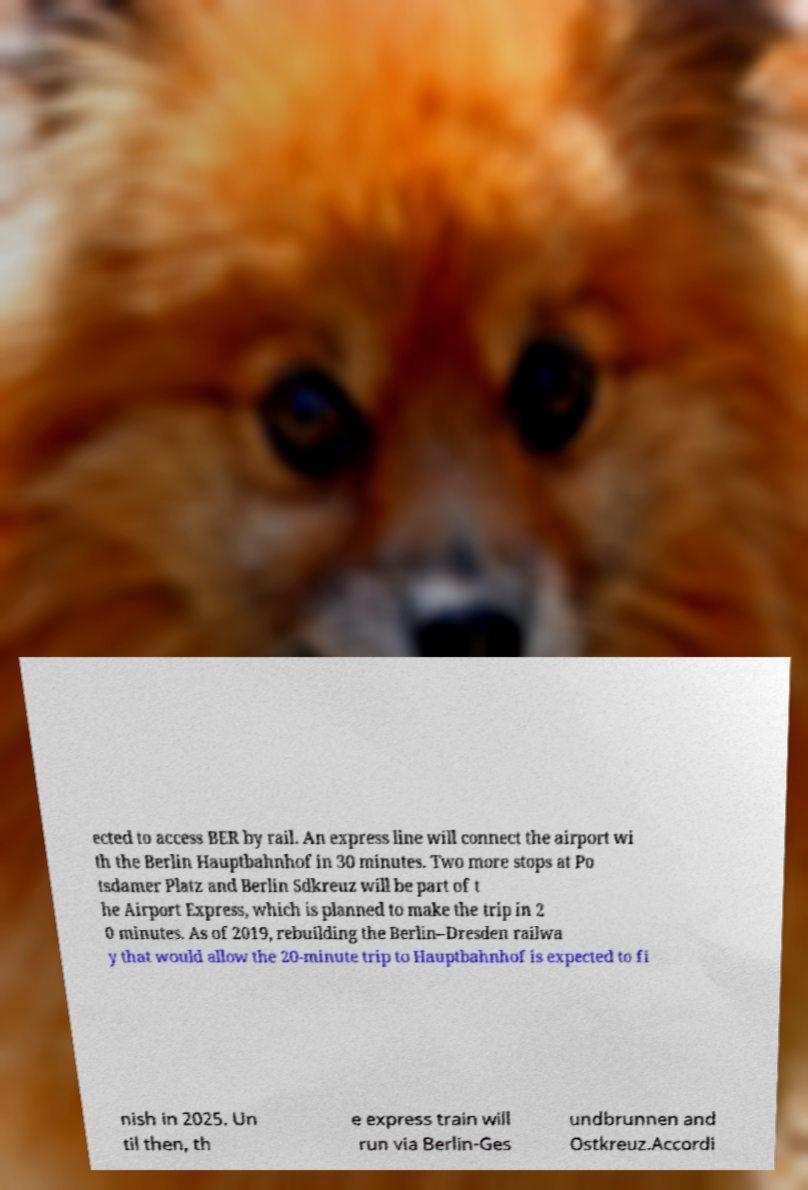I need the written content from this picture converted into text. Can you do that? ected to access BER by rail. An express line will connect the airport wi th the Berlin Hauptbahnhof in 30 minutes. Two more stops at Po tsdamer Platz and Berlin Sdkreuz will be part of t he Airport Express, which is planned to make the trip in 2 0 minutes. As of 2019, rebuilding the Berlin–Dresden railwa y that would allow the 20-minute trip to Hauptbahnhof is expected to fi nish in 2025. Un til then, th e express train will run via Berlin-Ges undbrunnen and Ostkreuz.Accordi 